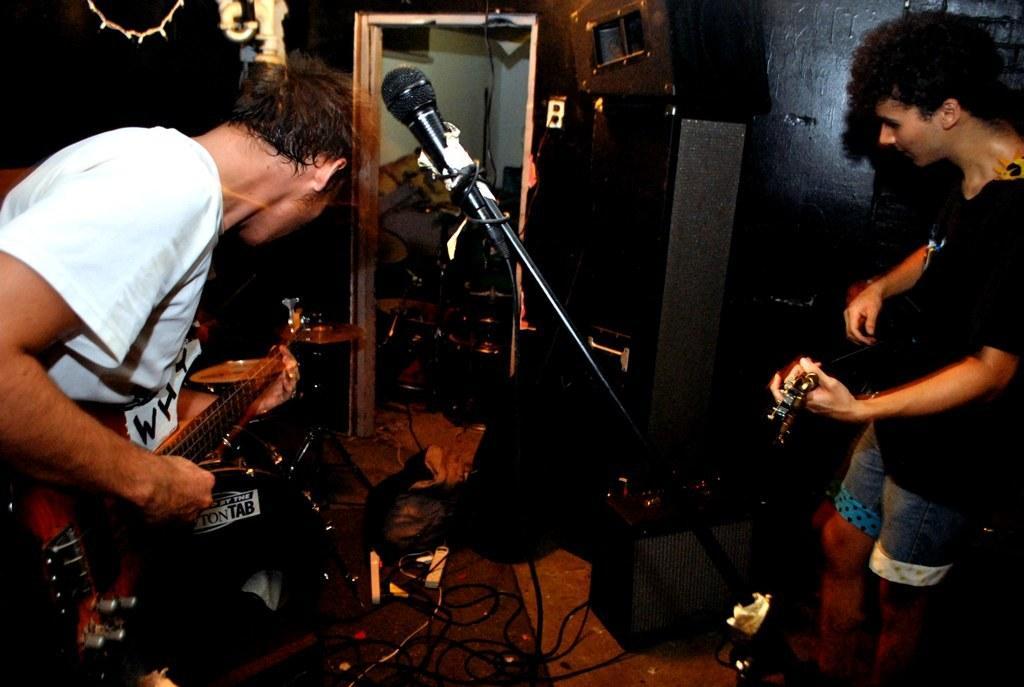Please provide a concise description of this image. In the image we can see there are people who are standing and holding guitar in their hand and in front there is a mic with a stand at the back there is speakers and on the ground there are wire which are connected to the plug. 